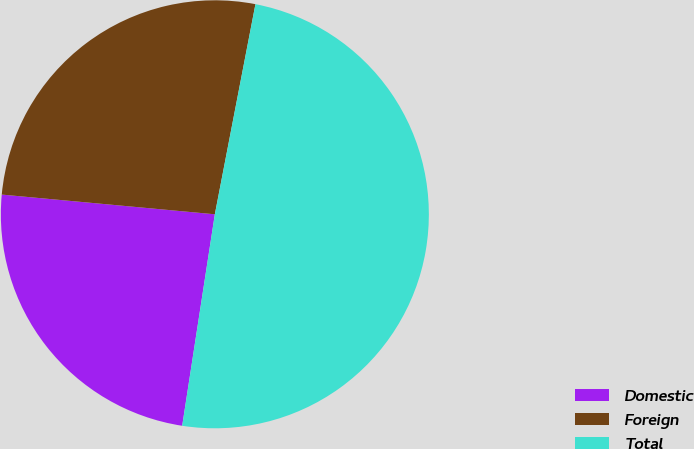<chart> <loc_0><loc_0><loc_500><loc_500><pie_chart><fcel>Domestic<fcel>Foreign<fcel>Total<nl><fcel>24.03%<fcel>26.57%<fcel>49.4%<nl></chart> 